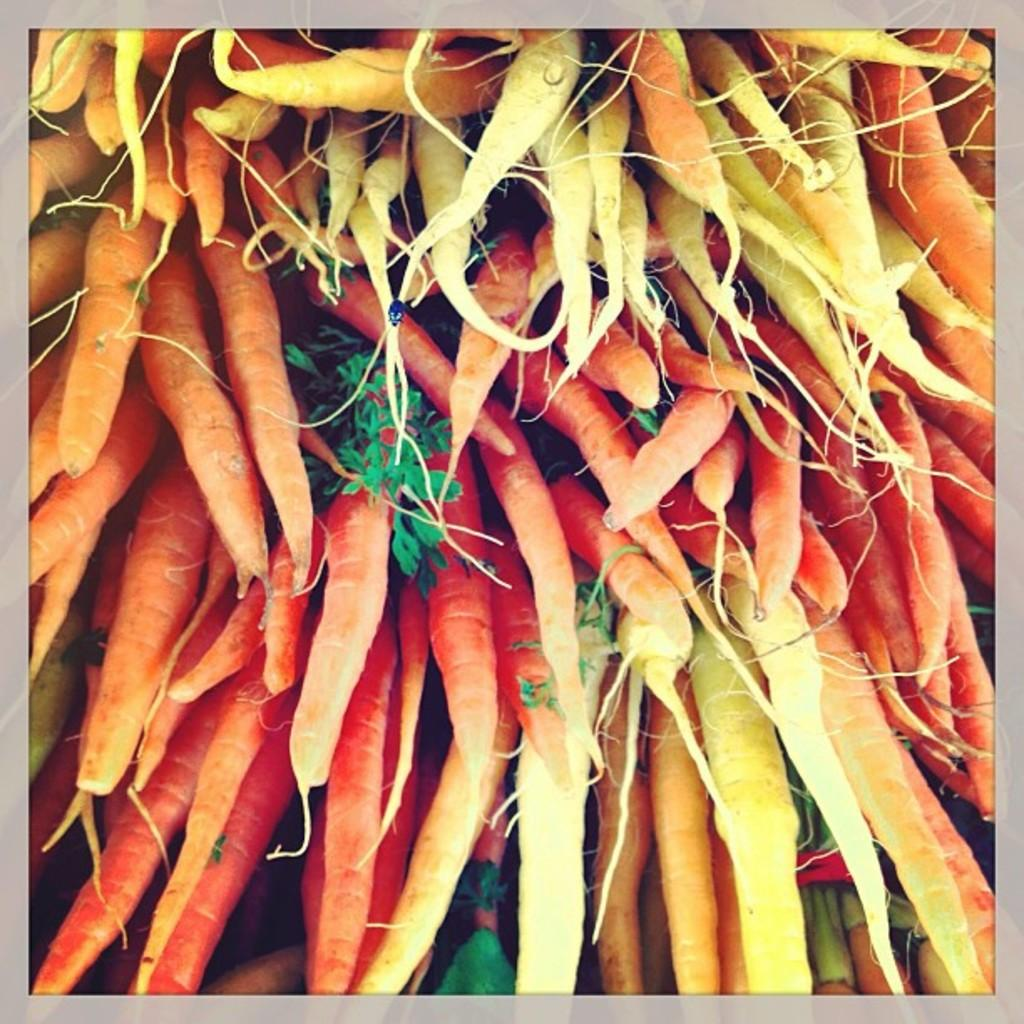What type of vegetable can be seen in the image? There are carrots in the image. What other plant-related elements are present in the image? There are leaves in the image. How many crates are visible in the image? There are no crates present in the image. What type of salt can be seen on the carrots in the image? There is no salt visible on the carrots in the image. 